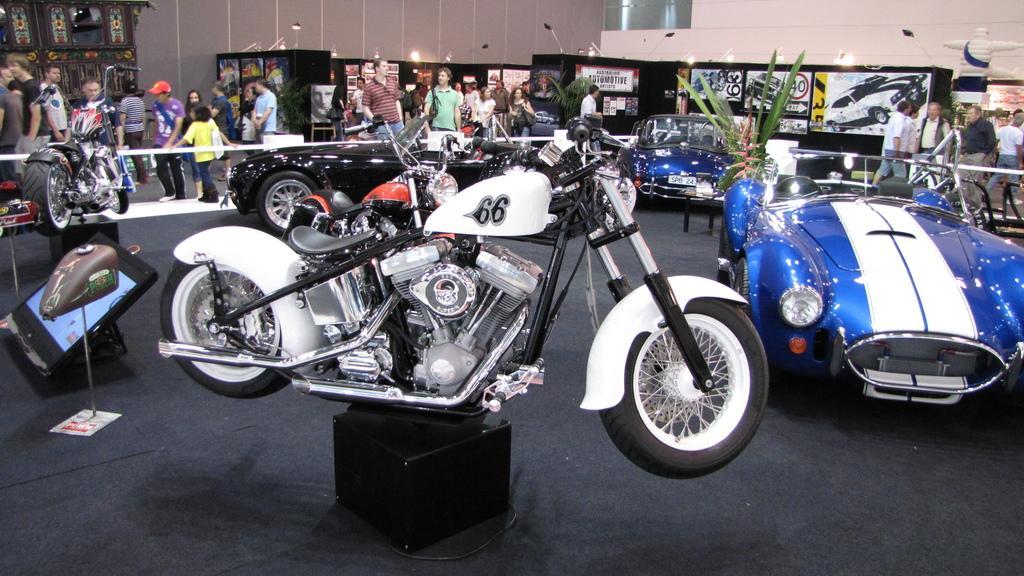Can you describe this image briefly? In this picture I can see there is a motorcycle, a car on to right and there is another car and a motor cycle, they are placed for display and there is a fence around them. There are few people standing and watching them, in the backdrop there are few lights and images of the cars. 